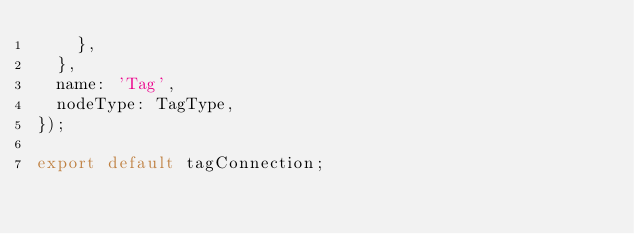<code> <loc_0><loc_0><loc_500><loc_500><_JavaScript_>    },
  },
  name: 'Tag',
  nodeType: TagType,
});

export default tagConnection;
</code> 